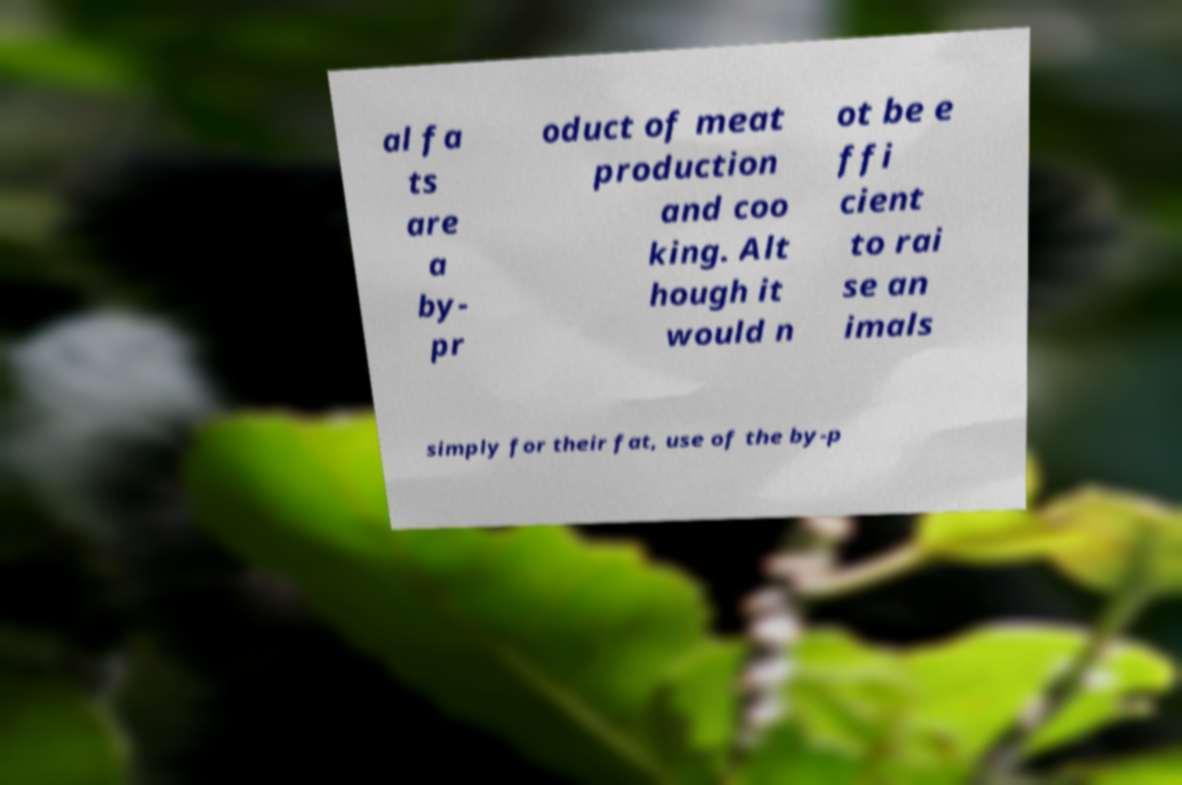There's text embedded in this image that I need extracted. Can you transcribe it verbatim? al fa ts are a by- pr oduct of meat production and coo king. Alt hough it would n ot be e ffi cient to rai se an imals simply for their fat, use of the by-p 